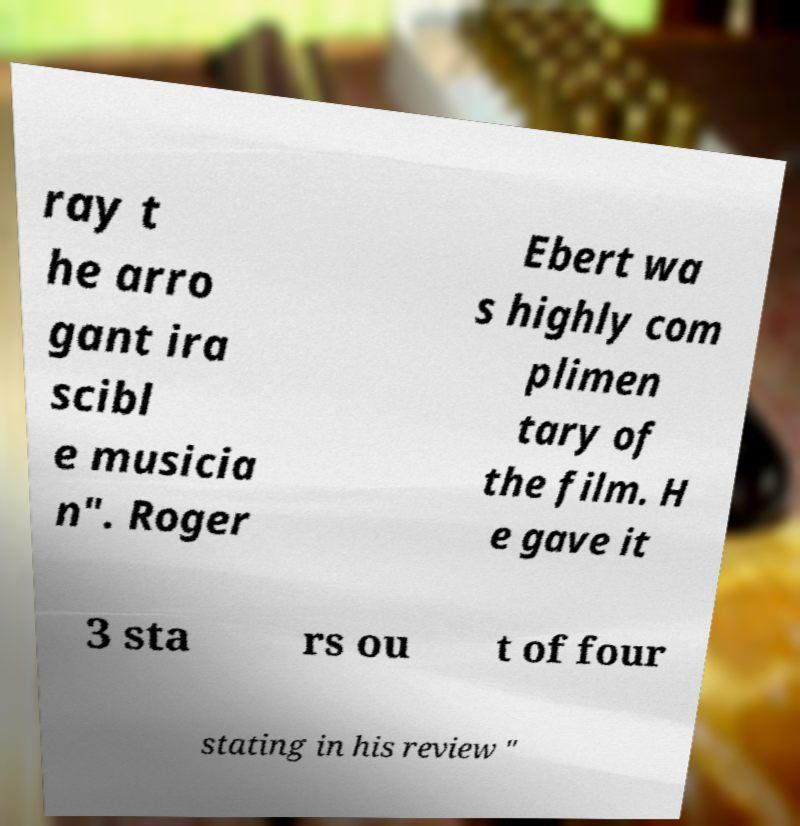Please identify and transcribe the text found in this image. ray t he arro gant ira scibl e musicia n". Roger Ebert wa s highly com plimen tary of the film. H e gave it 3 sta rs ou t of four stating in his review " 